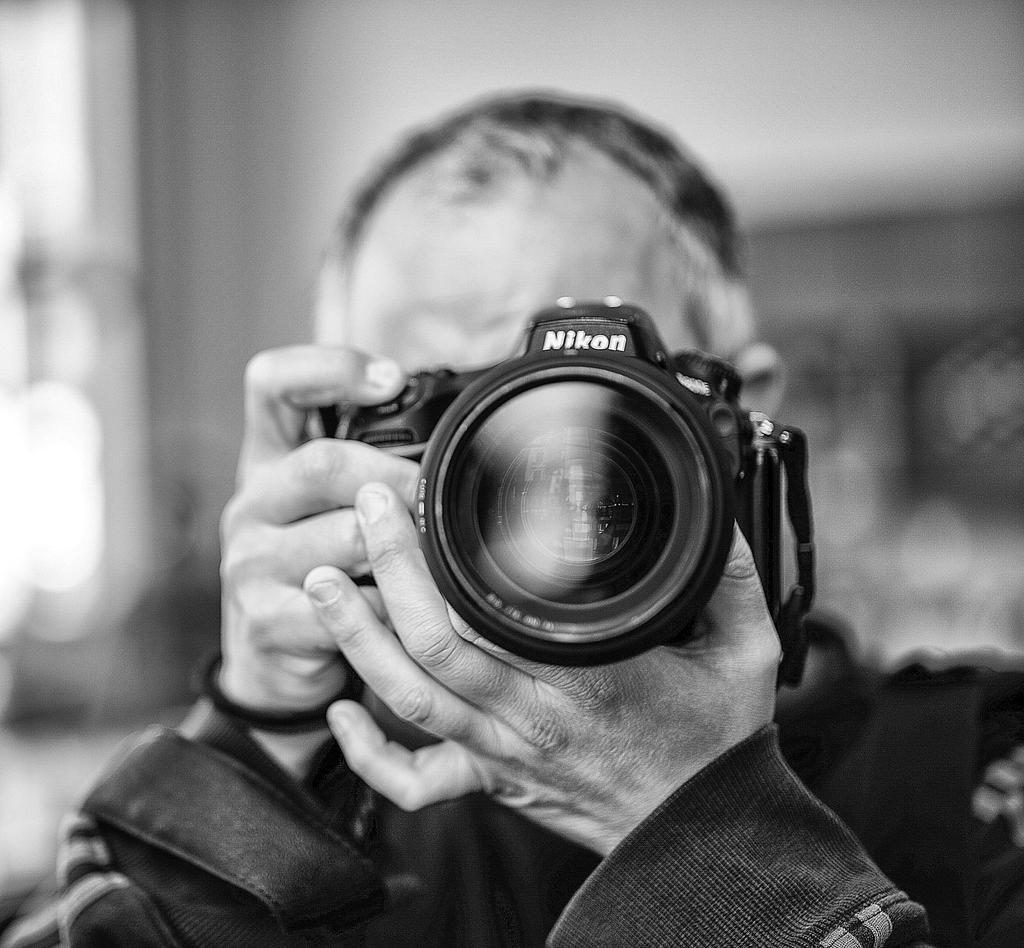What is the main subject of the image? There is a person in the image. What is the person holding in his hand? The person is holding a camera in his hand. What is the color scheme of the image? The image is black and white. How would you describe the background of the image? The background of the image is blurred. What is the size of the crow in the image? There is no crow present in the image. What type of grain is visible in the image? The image is black and white, so there is no visible grain. 